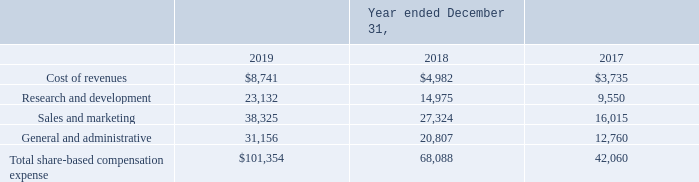Note 11. Share-Based Compensation
A summary of share-based compensation expense recognized in the Company’s Consolidated Statements of Operations is as follows (in thousands):
What are the respective share-based compensation for cost of revenues in 2018 and 2019?
Answer scale should be: thousand. $4,982, $8,741. What are the respective share-based compensation for research and development in 2018 and 2019?
Answer scale should be: thousand. 14,975, 23,132. What are the respective share-based compensation for sales and marketing in 2018 and 2019?
Answer scale should be: thousand. 27,324, 38,325. What is the percentage change in share-based compensation for research and development between 2018 and 2019?
Answer scale should be: percent. (23,132 - 14,975)/14,975 
Answer: 54.47. What is the percentage change in share-based compensation for sales and marketing between 2018 and 2019?
Answer scale should be: percent. (31,156 - 20,807)/20,807 
Answer: 49.74. What is the average share-based compensation expense spent on sales and marketing per year between 2017 to 2019?
Answer scale should be: thousand. (38,325 + 27,324 + 16,015)/3 
Answer: 27221.33. 